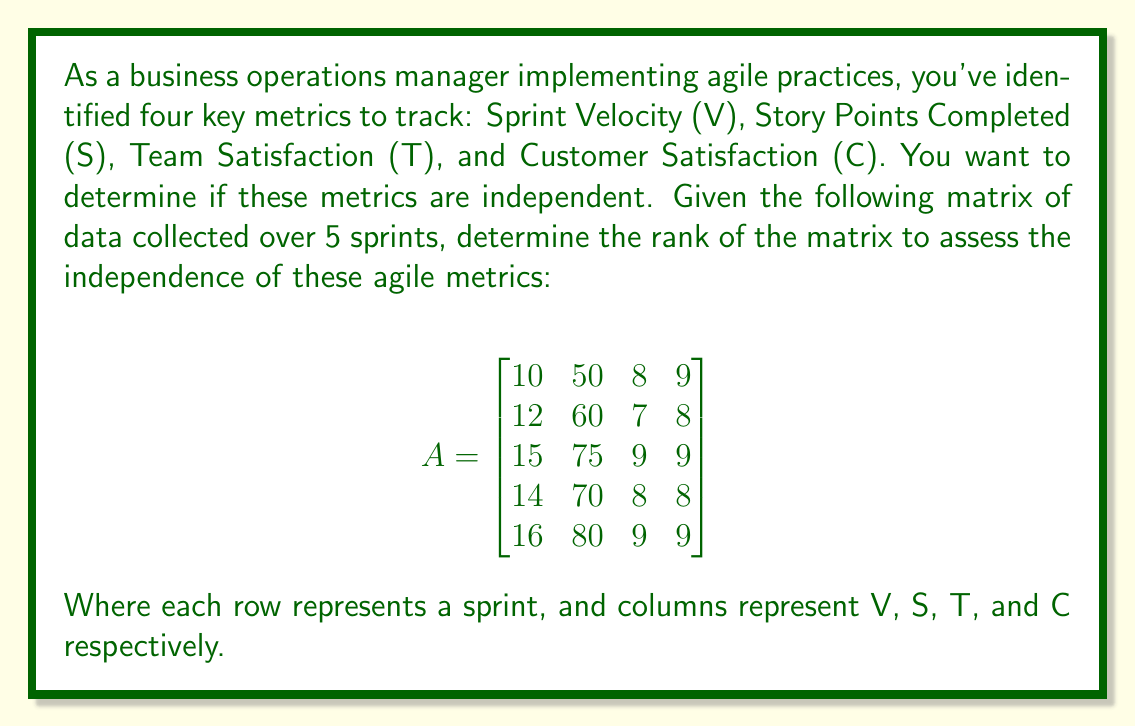What is the answer to this math problem? To determine the rank of matrix A, we need to follow these steps:

1) First, let's convert the matrix to row echelon form using Gaussian elimination:

$$
\begin{bmatrix}
10 & 50 & 8 & 9 \\
12 & 60 & 7 & 8 \\
15 & 75 & 9 & 9 \\
14 & 70 & 8 & 8 \\
16 & 80 & 9 & 9
\end{bmatrix}
$$

2) Divide the first row by 10:

$$
\begin{bmatrix}
1 & 5 & 0.8 & 0.9 \\
12 & 60 & 7 & 8 \\
15 & 75 & 9 & 9 \\
14 & 70 & 8 & 8 \\
16 & 80 & 9 & 9
\end{bmatrix}
$$

3) Subtract 12 times the first row from the second row, 15 times from the third, 14 times from the fourth, and 16 times from the fifth:

$$
\begin{bmatrix}
1 & 5 & 0.8 & 0.9 \\
0 & 0 & -2.6 & -2.8 \\
0 & 0 & -3 & -4.5 \\
0 & 0 & -3.2 & -4.6 \\
0 & 0 & -3.8 & -5.4
\end{bmatrix}
$$

4) Now, focus on the second non-zero row. Divide it by -2.6:

$$
\begin{bmatrix}
1 & 5 & 0.8 & 0.9 \\
0 & 0 & 1 & 1.0769 \\
0 & 0 & -3 & -4.5 \\
0 & 0 & -3.2 & -4.6 \\
0 & 0 & -3.8 & -5.4
\end{bmatrix}
$$

5) Add 3 times the second row to the third, 3.2 times to the fourth, and 3.8 times to the fifth:

$$
\begin{bmatrix}
1 & 5 & 0.8 & 0.9 \\
0 & 0 & 1 & 1.0769 \\
0 & 0 & 0 & -1.2692 \\
0 & 0 & 0 & -1.1538 \\
0 & 0 & 0 & -1.3077
\end{bmatrix}
$$

6) The matrix is now in row echelon form. The rank of the matrix is equal to the number of non-zero rows, which is 3.

This means that out of the four metrics, only three are linearly independent. Specifically, the Sprint Velocity (V) and Story Points Completed (S) are perfectly correlated (S = 5V), while the other two metrics (T and C) provide additional independent information.
Answer: Rank = 3 